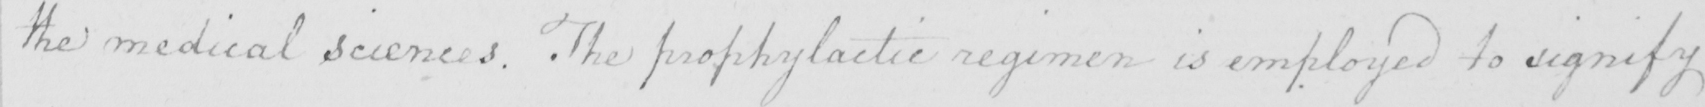Can you tell me what this handwritten text says? the medical sciences . The prophylactic regimen is employed to signify 